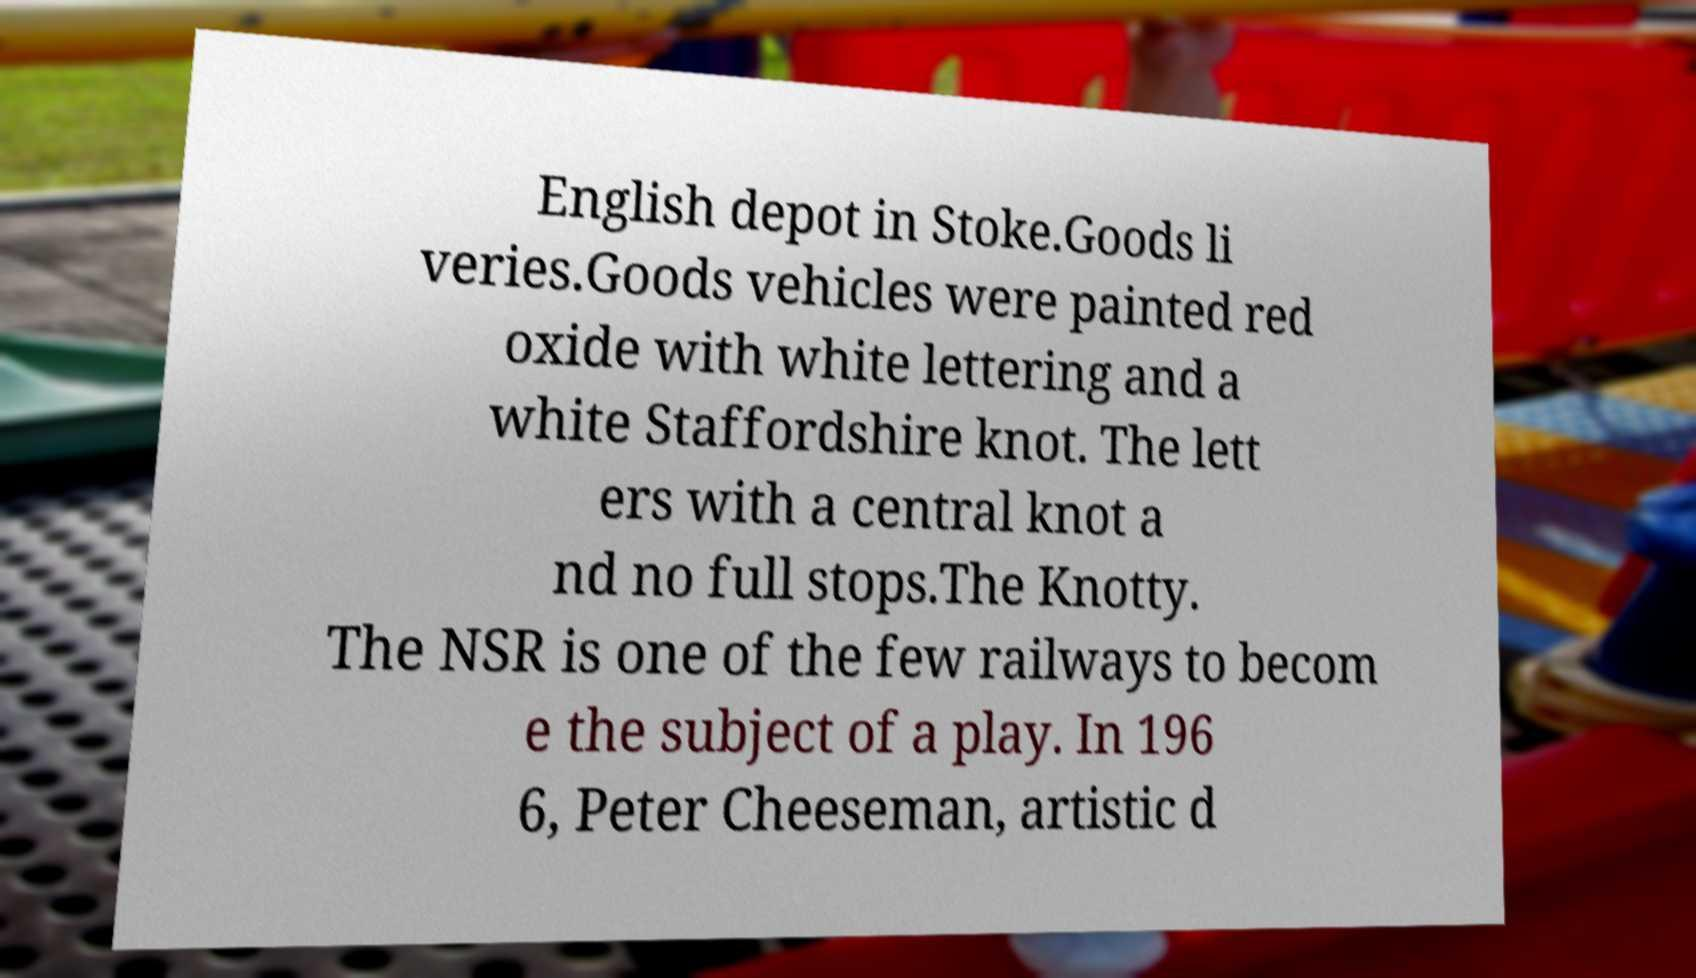There's text embedded in this image that I need extracted. Can you transcribe it verbatim? English depot in Stoke.Goods li veries.Goods vehicles were painted red oxide with white lettering and a white Staffordshire knot. The lett ers with a central knot a nd no full stops.The Knotty. The NSR is one of the few railways to becom e the subject of a play. In 196 6, Peter Cheeseman, artistic d 